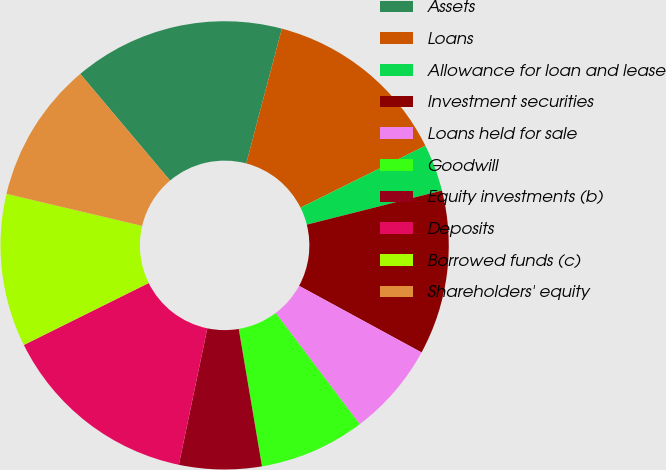<chart> <loc_0><loc_0><loc_500><loc_500><pie_chart><fcel>Assets<fcel>Loans<fcel>Allowance for loan and lease<fcel>Investment securities<fcel>Loans held for sale<fcel>Goodwill<fcel>Equity investments (b)<fcel>Deposits<fcel>Borrowed funds (c)<fcel>Shareholders' equity<nl><fcel>15.25%<fcel>13.56%<fcel>3.4%<fcel>11.86%<fcel>6.78%<fcel>7.63%<fcel>5.94%<fcel>14.4%<fcel>11.02%<fcel>10.17%<nl></chart> 